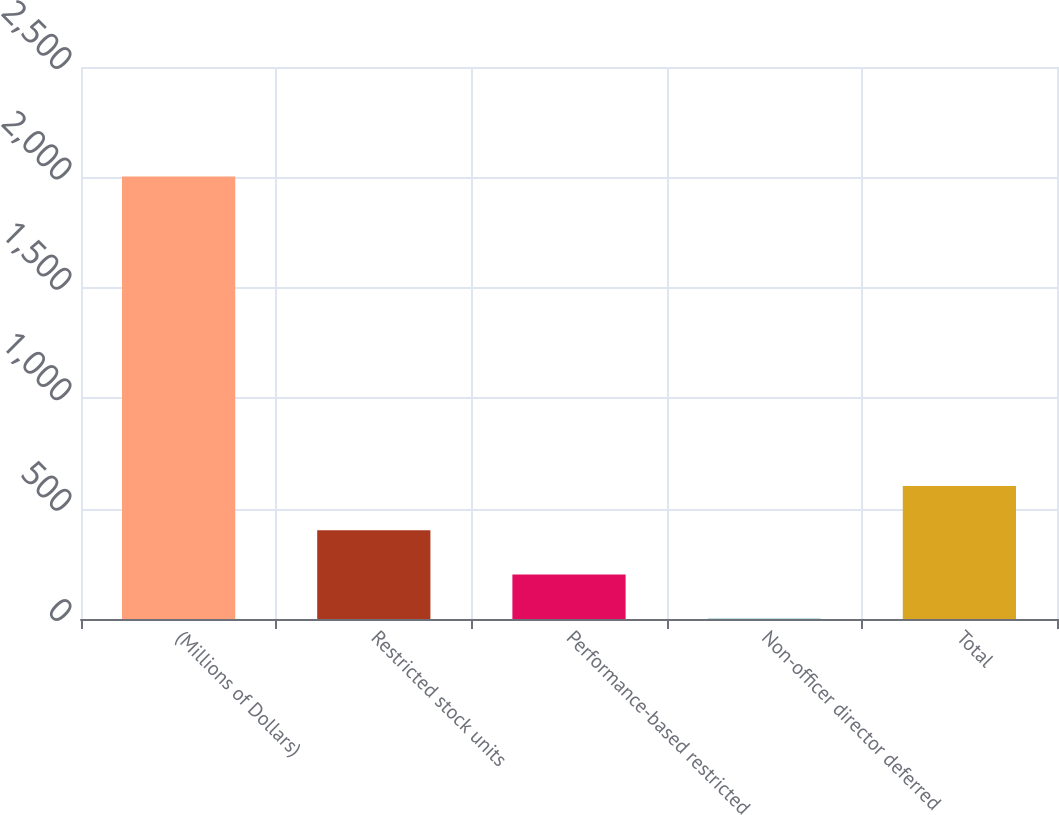<chart> <loc_0><loc_0><loc_500><loc_500><bar_chart><fcel>(Millions of Dollars)<fcel>Restricted stock units<fcel>Performance-based restricted<fcel>Non-officer director deferred<fcel>Total<nl><fcel>2004<fcel>401.6<fcel>201.3<fcel>1<fcel>601.9<nl></chart> 